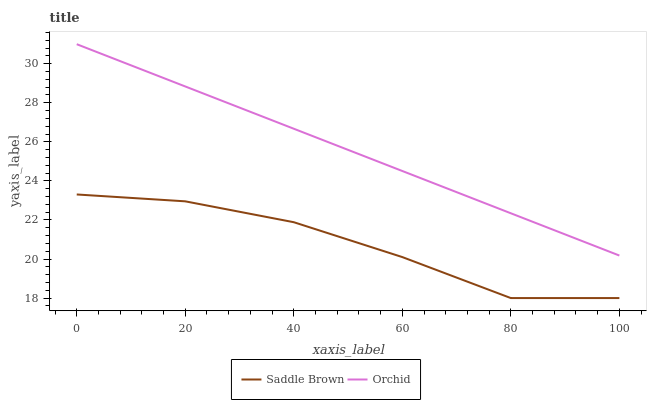Does Orchid have the minimum area under the curve?
Answer yes or no. No. Is Orchid the roughest?
Answer yes or no. No. Does Orchid have the lowest value?
Answer yes or no. No. Is Saddle Brown less than Orchid?
Answer yes or no. Yes. Is Orchid greater than Saddle Brown?
Answer yes or no. Yes. Does Saddle Brown intersect Orchid?
Answer yes or no. No. 